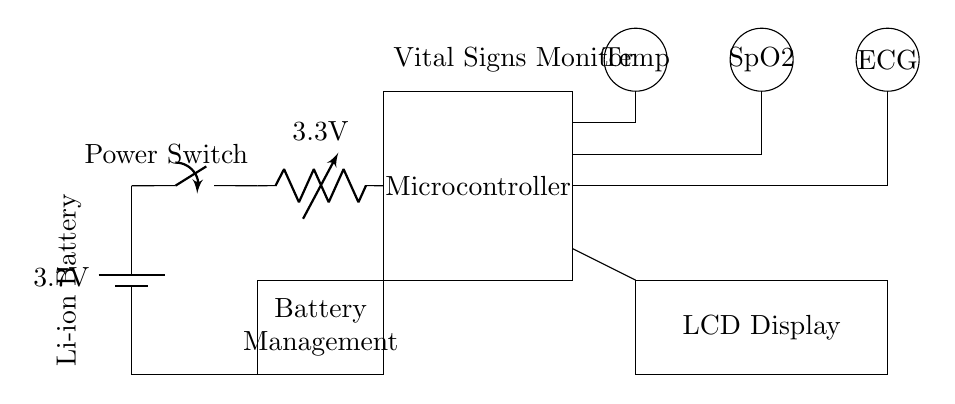What is the voltage of the battery? The voltage of the battery is specified as 3.7 volts in the circuit diagram. This value indicates the potential difference provided by the battery.
Answer: 3.7 volts What components are connected to the microcontroller? The microcontroller is connected to three sensors: Temperature, SpO2, and ECG. These connections can be seen by tracing the lines from the microcontroller to each sensor in the circuit diagram.
Answer: Temperature, SpO2, ECG What voltage does the voltage regulator output? The voltage regulator is marked with an output voltage of 3.3 volts. This means that it reduces the input voltage from the battery to a lower, stable output suitable for the circuit components downstream.
Answer: 3.3 volts Why is a battery management system included in the circuit? A battery management system is crucial for monitoring the battery's state, preventing overcharging, and ensuring safe operation. It is located between the battery and the rest of the circuit, indicating its role in managing battery health and safety.
Answer: To monitor battery state What type of battery is indicated in this circuit? The circuit indicates a Li-ion battery, which is commonly used in portable devices due to its high energy density and lighter weight compared to other battery types. This information can be found on the battery label in the circuit.
Answer: Li-ion What is the purpose of the LCD display in the circuit? The LCD display is used to present vital signs data to the user, allowing for monitoring of the patient's health metrics in real-time. It is connected to the microcontroller, which processes the data from the sensors and sends it to be displayed.
Answer: To present vital signs data 